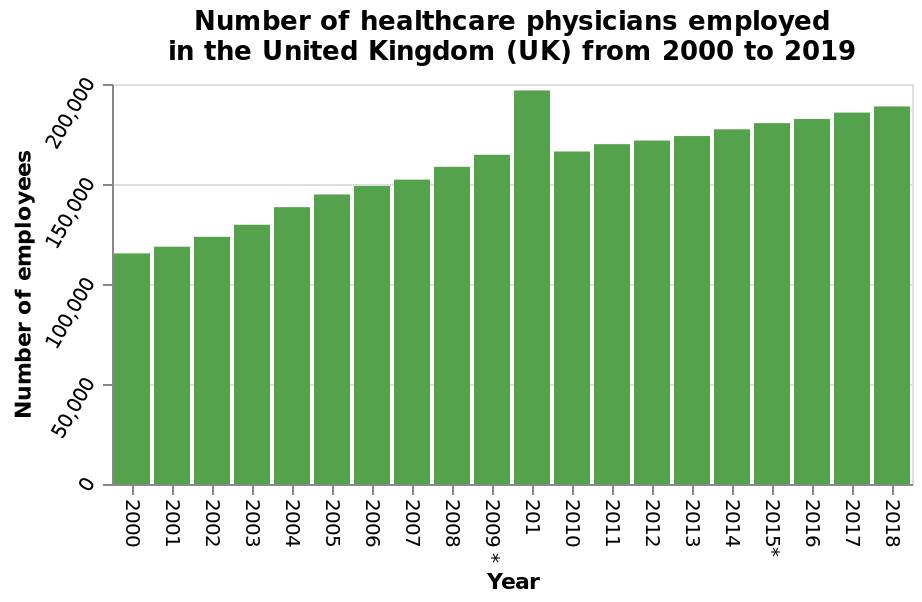<image>
What time period does the bar graph cover? The bar graph covers the years from 2000 to 2019. What is the maximum number of healthcare physicians employed in the UK during the given time period? The bar graph does not provide information about the maximum number of healthcare physicians employed in the UK during the given time period. In which year did the spike of employment in the health care sector occur?  The spike of employment in the health care sector occurred between 2009 and 2010. What is the range of the x-axis on the bar graph? The range of the x-axis on the bar graph is from 2000 to 2018. 